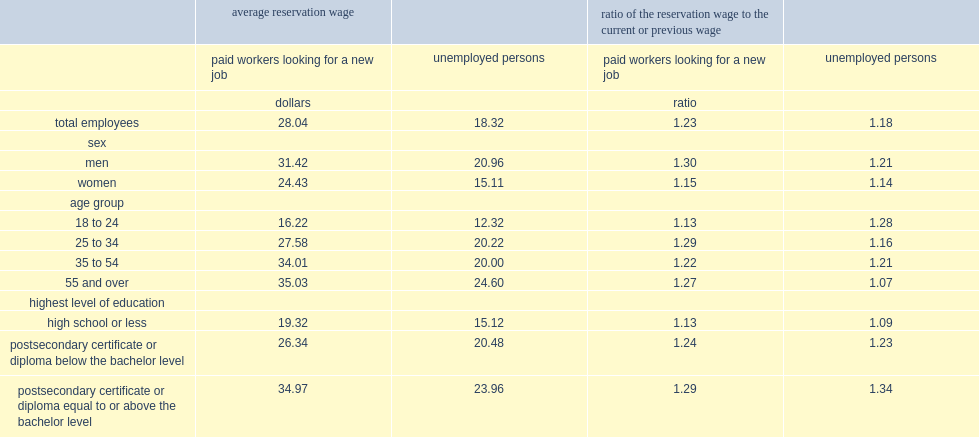On average, what is the rate of workers looking for a new job wanted to earn more than their current wage? 23.18. 